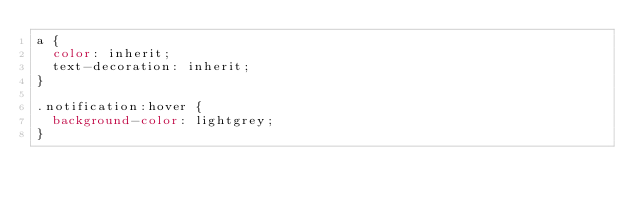<code> <loc_0><loc_0><loc_500><loc_500><_CSS_>a {
  color: inherit;
  text-decoration: inherit;
}

.notification:hover {
  background-color: lightgrey;
}
</code> 